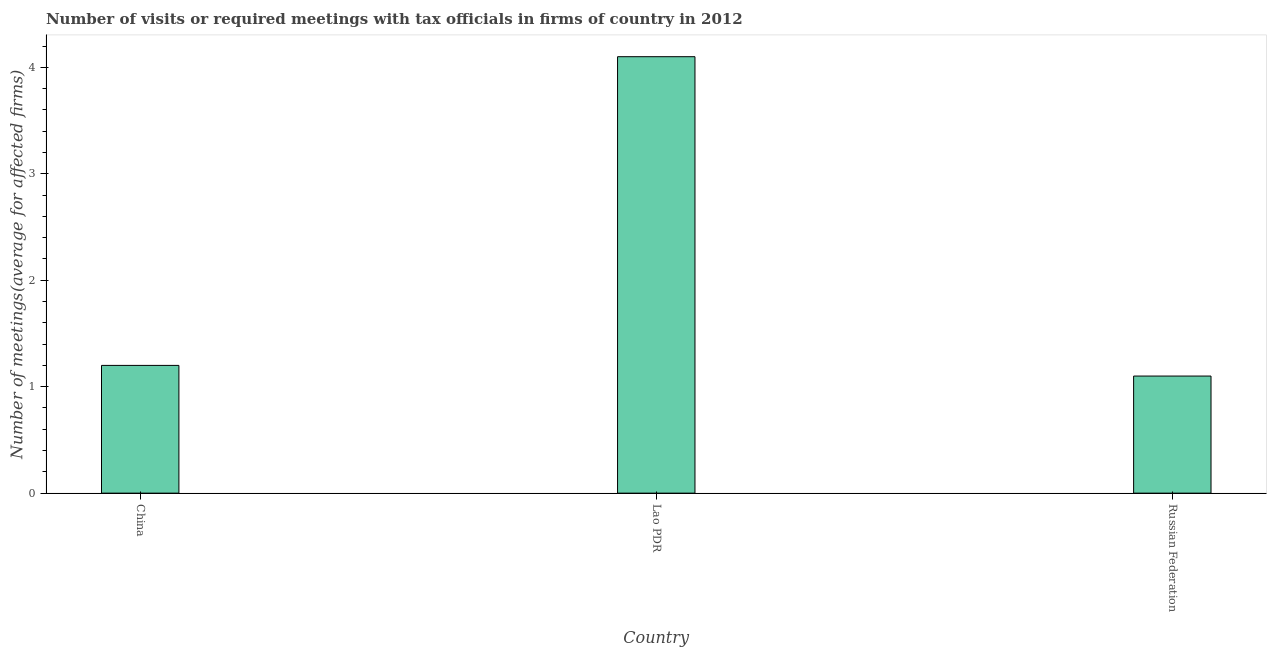Does the graph contain any zero values?
Offer a terse response. No. Does the graph contain grids?
Your answer should be compact. No. What is the title of the graph?
Keep it short and to the point. Number of visits or required meetings with tax officials in firms of country in 2012. What is the label or title of the X-axis?
Give a very brief answer. Country. What is the label or title of the Y-axis?
Your answer should be very brief. Number of meetings(average for affected firms). Across all countries, what is the maximum number of required meetings with tax officials?
Make the answer very short. 4.1. Across all countries, what is the minimum number of required meetings with tax officials?
Offer a very short reply. 1.1. In which country was the number of required meetings with tax officials maximum?
Offer a very short reply. Lao PDR. In which country was the number of required meetings with tax officials minimum?
Your answer should be compact. Russian Federation. What is the sum of the number of required meetings with tax officials?
Ensure brevity in your answer.  6.4. What is the difference between the number of required meetings with tax officials in Lao PDR and Russian Federation?
Ensure brevity in your answer.  3. What is the average number of required meetings with tax officials per country?
Give a very brief answer. 2.13. What is the median number of required meetings with tax officials?
Your answer should be very brief. 1.2. In how many countries, is the number of required meetings with tax officials greater than 3.8 ?
Your answer should be very brief. 1. What is the ratio of the number of required meetings with tax officials in China to that in Lao PDR?
Provide a short and direct response. 0.29. Is the difference between the number of required meetings with tax officials in China and Russian Federation greater than the difference between any two countries?
Your response must be concise. No. How many bars are there?
Ensure brevity in your answer.  3. Are all the bars in the graph horizontal?
Give a very brief answer. No. What is the difference between two consecutive major ticks on the Y-axis?
Provide a succinct answer. 1. What is the Number of meetings(average for affected firms) in China?
Offer a terse response. 1.2. What is the difference between the Number of meetings(average for affected firms) in China and Lao PDR?
Provide a short and direct response. -2.9. What is the difference between the Number of meetings(average for affected firms) in Lao PDR and Russian Federation?
Provide a succinct answer. 3. What is the ratio of the Number of meetings(average for affected firms) in China to that in Lao PDR?
Offer a very short reply. 0.29. What is the ratio of the Number of meetings(average for affected firms) in China to that in Russian Federation?
Your answer should be very brief. 1.09. What is the ratio of the Number of meetings(average for affected firms) in Lao PDR to that in Russian Federation?
Provide a short and direct response. 3.73. 